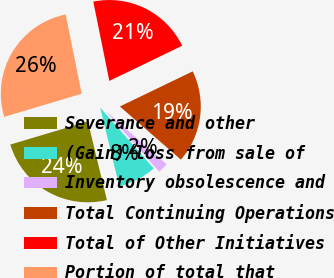<chart> <loc_0><loc_0><loc_500><loc_500><pie_chart><fcel>Severance and other<fcel>(Gain) loss from sale of<fcel>Inventory obsolescence and<fcel>Total Continuing Operations<fcel>Total of Other Initiatives<fcel>Portion of total that<nl><fcel>24.17%<fcel>7.71%<fcel>2.1%<fcel>18.56%<fcel>21.02%<fcel>26.44%<nl></chart> 